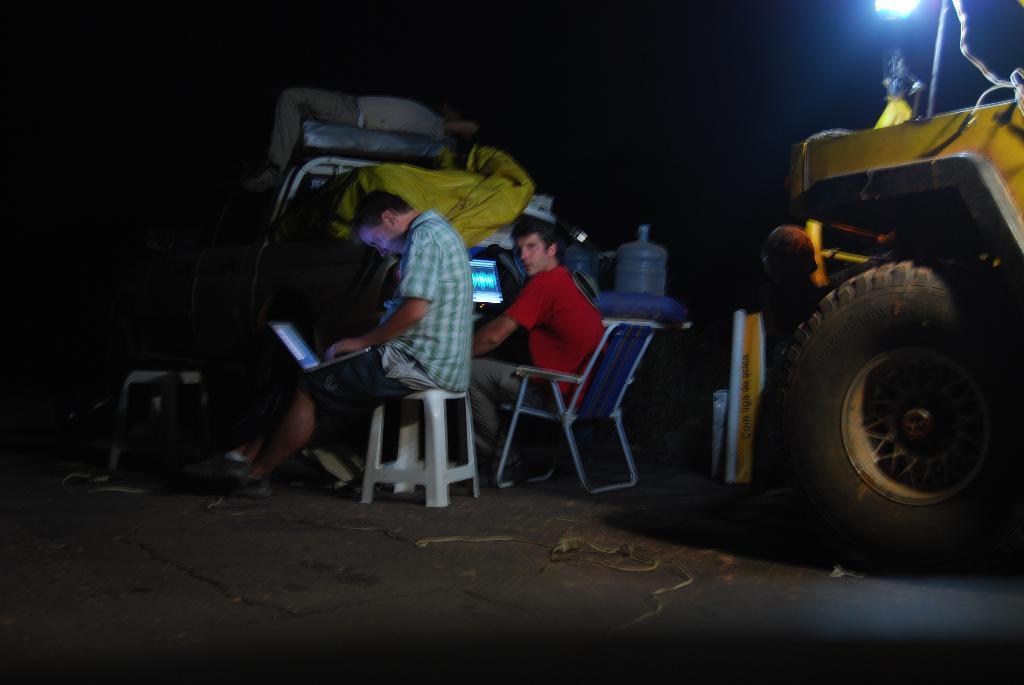In one or two sentences, can you explain what this image depicts? In this image we can see two persons, chairs, laptops, water can, vehicle and we can also see a dark background. 